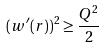<formula> <loc_0><loc_0><loc_500><loc_500>( w ^ { \prime } ( r ) ) ^ { 2 } \geq \frac { Q ^ { 2 } } { 2 }</formula> 